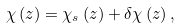<formula> <loc_0><loc_0><loc_500><loc_500>\chi \left ( z \right ) = \chi _ { s } \left ( z \right ) + \delta \chi \left ( z \right ) ,</formula> 